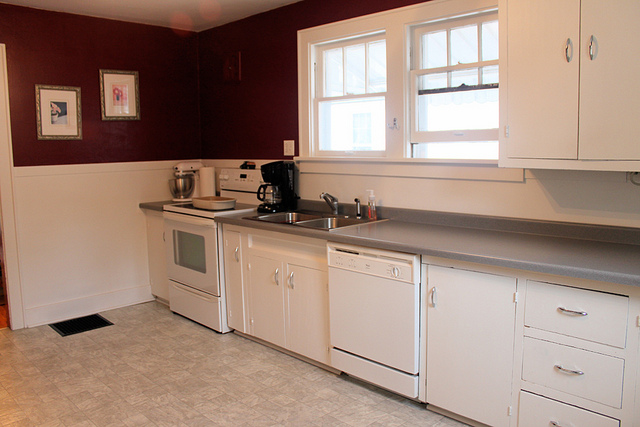What kind of room is depicted in the image? The image depicts a kitchen, complete with appliances and cabinetry typically found in such a room. 